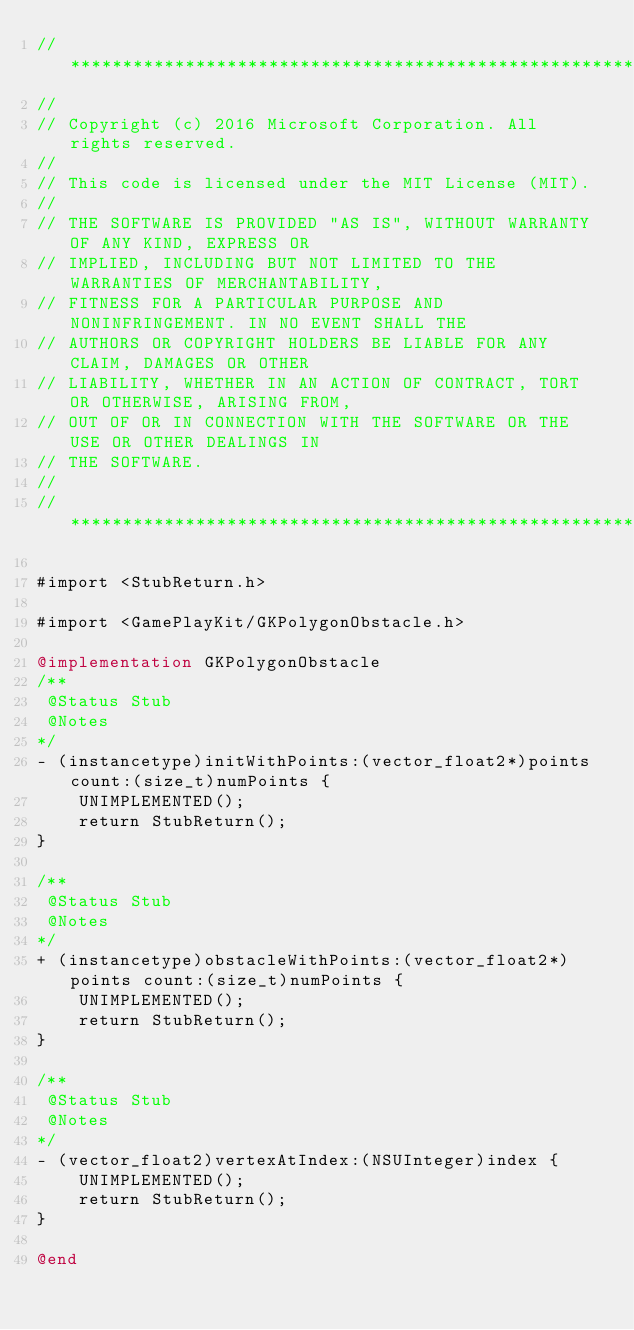<code> <loc_0><loc_0><loc_500><loc_500><_ObjectiveC_>//******************************************************************************
//
// Copyright (c) 2016 Microsoft Corporation. All rights reserved.
//
// This code is licensed under the MIT License (MIT).
//
// THE SOFTWARE IS PROVIDED "AS IS", WITHOUT WARRANTY OF ANY KIND, EXPRESS OR
// IMPLIED, INCLUDING BUT NOT LIMITED TO THE WARRANTIES OF MERCHANTABILITY,
// FITNESS FOR A PARTICULAR PURPOSE AND NONINFRINGEMENT. IN NO EVENT SHALL THE
// AUTHORS OR COPYRIGHT HOLDERS BE LIABLE FOR ANY CLAIM, DAMAGES OR OTHER
// LIABILITY, WHETHER IN AN ACTION OF CONTRACT, TORT OR OTHERWISE, ARISING FROM,
// OUT OF OR IN CONNECTION WITH THE SOFTWARE OR THE USE OR OTHER DEALINGS IN
// THE SOFTWARE.
//
//******************************************************************************

#import <StubReturn.h>

#import <GamePlayKit/GKPolygonObstacle.h>

@implementation GKPolygonObstacle
/**
 @Status Stub
 @Notes
*/
- (instancetype)initWithPoints:(vector_float2*)points count:(size_t)numPoints {
    UNIMPLEMENTED();
    return StubReturn();
}

/**
 @Status Stub
 @Notes
*/
+ (instancetype)obstacleWithPoints:(vector_float2*)points count:(size_t)numPoints {
    UNIMPLEMENTED();
    return StubReturn();
}

/**
 @Status Stub
 @Notes
*/
- (vector_float2)vertexAtIndex:(NSUInteger)index {
    UNIMPLEMENTED();
    return StubReturn();
}

@end
</code> 